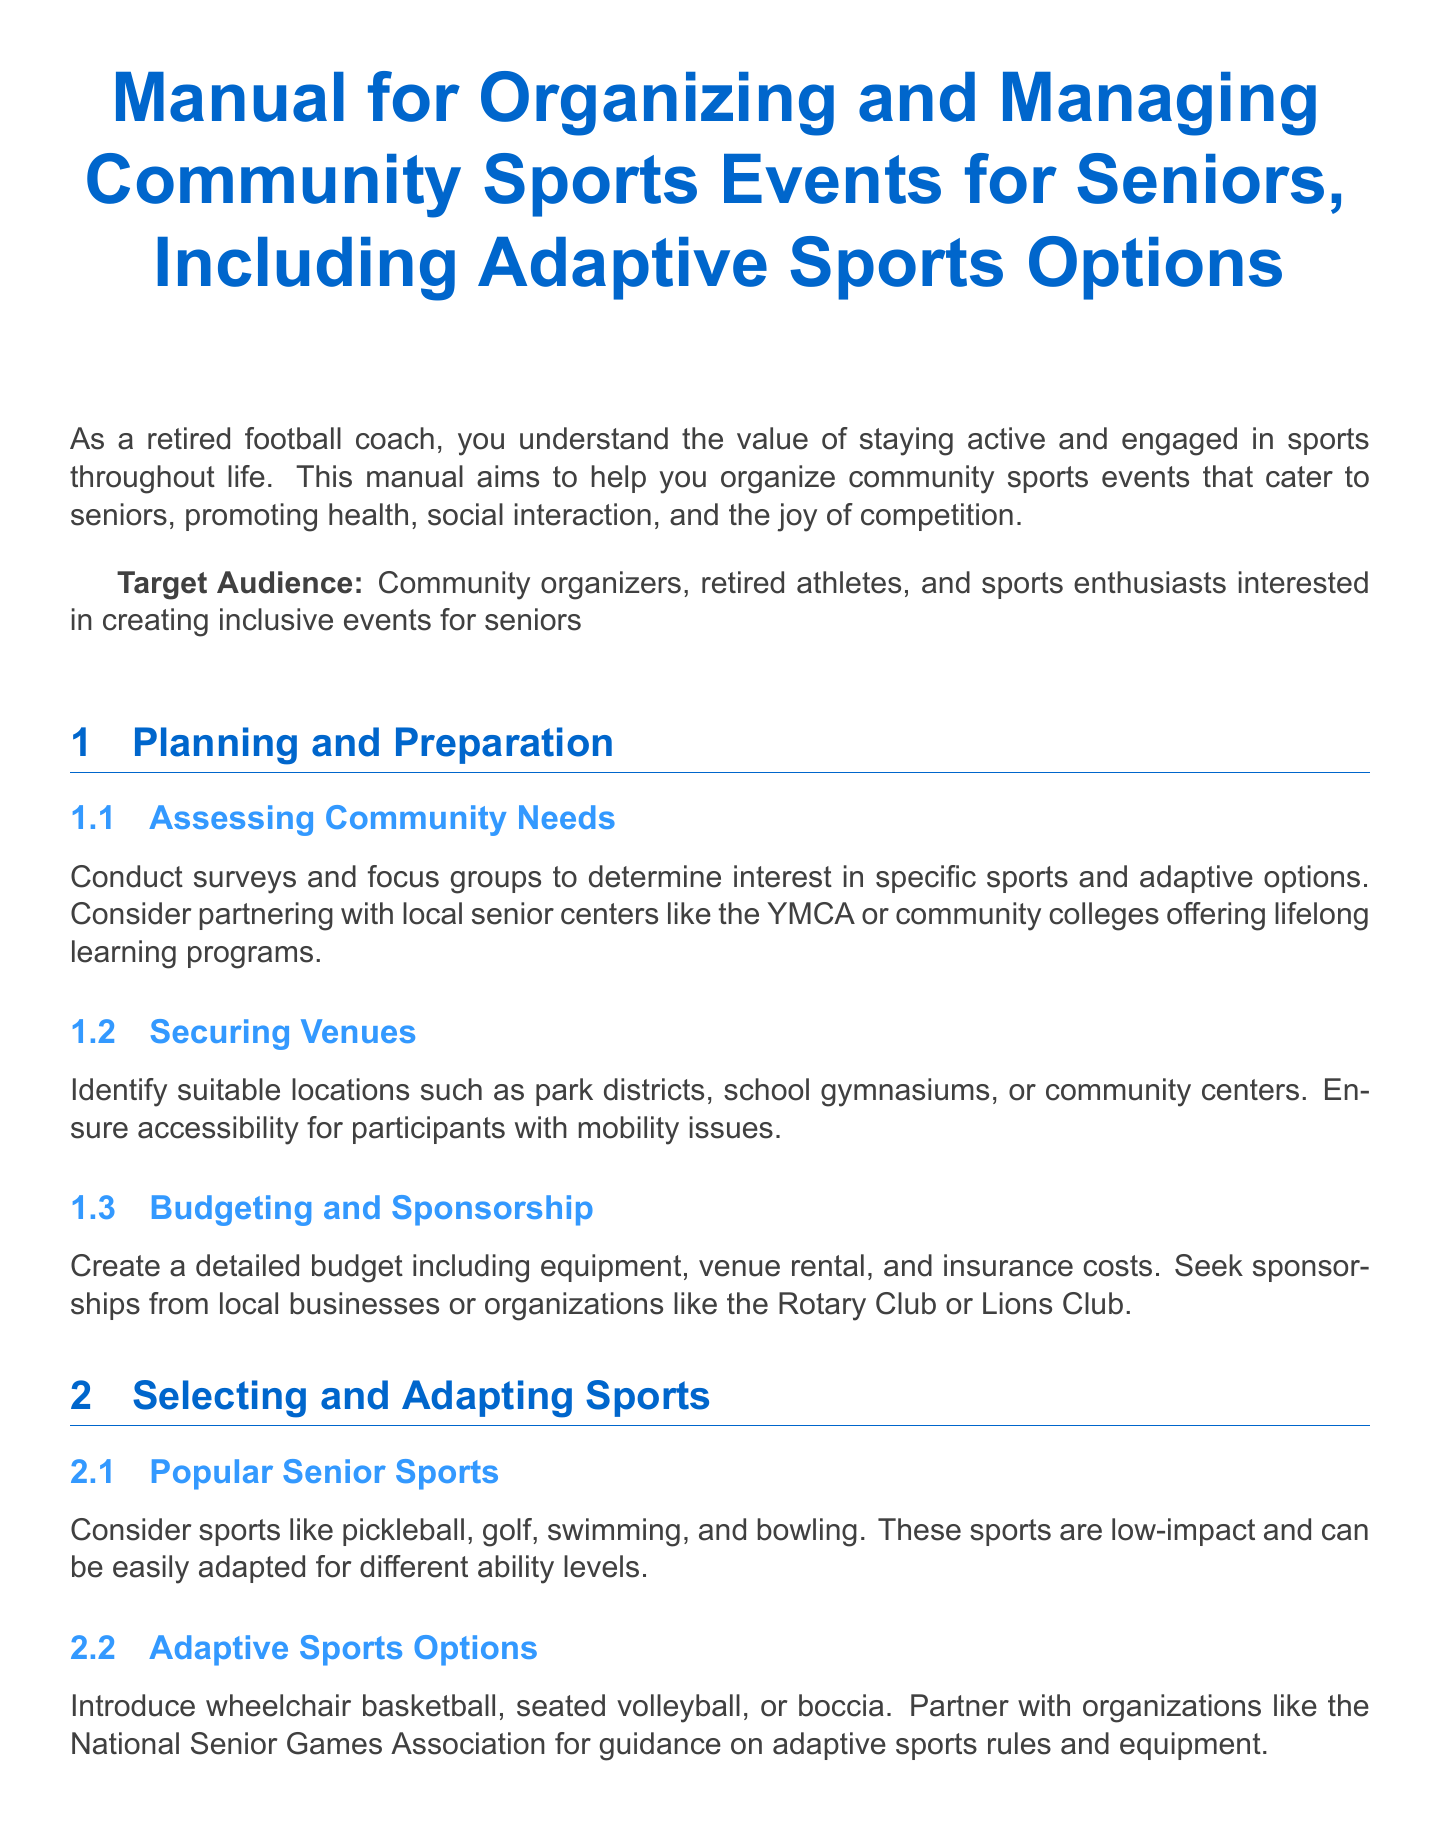what is the title of the manual? The title is located at the beginning of the document and outlines the main subject matter.
Answer: Manual for Organizing and Managing Community Sports Events for Seniors, Including Adaptive Sports Options who is the target audience? The target audience is explicitly mentioned in the introduction of the document.
Answer: Community organizers, retired athletes, and sports enthusiasts interested in creating inclusive events for seniors name one popular senior sport mentioned. Popular senior sports are listed under the corresponding section in the document, highlighting low-impact options.
Answer: Pickleball what is one adaptive sports option included? This information is found under the adaptive sports section that details options for inclusivity in sports.
Answer: Wheelchair basketball what should you develop for the registration process? The document specifies requirements for the registration process in the relevant section, indicating what to include.
Answer: Both online and paper registration forms how can community needs be assessed? The document describes methods for assessing community needs in the planning section.
Answer: Surveys and focus groups what should be considered for venue accessibility? The document emphasizes the importance of certain aspects that ensure all participants can attend the events.
Answer: Accessibility for participants with mobility issues what type of systems can be implemented for team formation? The document suggests strategies for creating balanced teams to support inclusivity among participants.
Answer: Buddy system which software is suggested for efficient scheduling? The document mentions specific software to help manage event logistics effectively.
Answer: Tourney Machine 